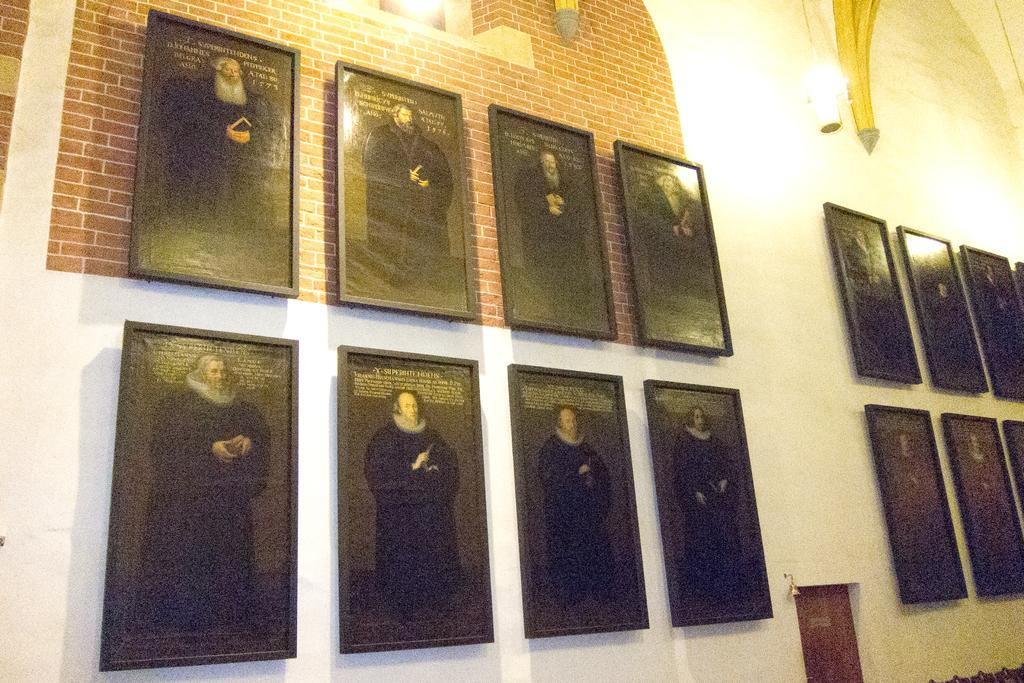What can be seen hanging on the wall in the image? There are frames on the wall in the image. What is a common feature of rooms that can be seen in the image? There is a door in the image. What type of illumination is present in the image? There are lights on the wall in the image. What type of jelly can be seen on the door in the image? There is no jelly present on the door in the image. How does the ice help to illuminate the room in the image? There is no ice present in the image, and it does not contribute to the illumination of the room. 